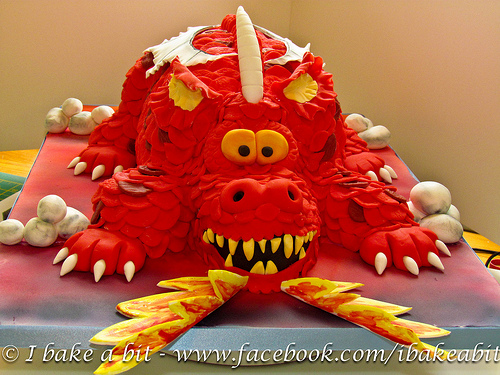<image>
Is the dragon on the platter? Yes. Looking at the image, I can see the dragon is positioned on top of the platter, with the platter providing support. 